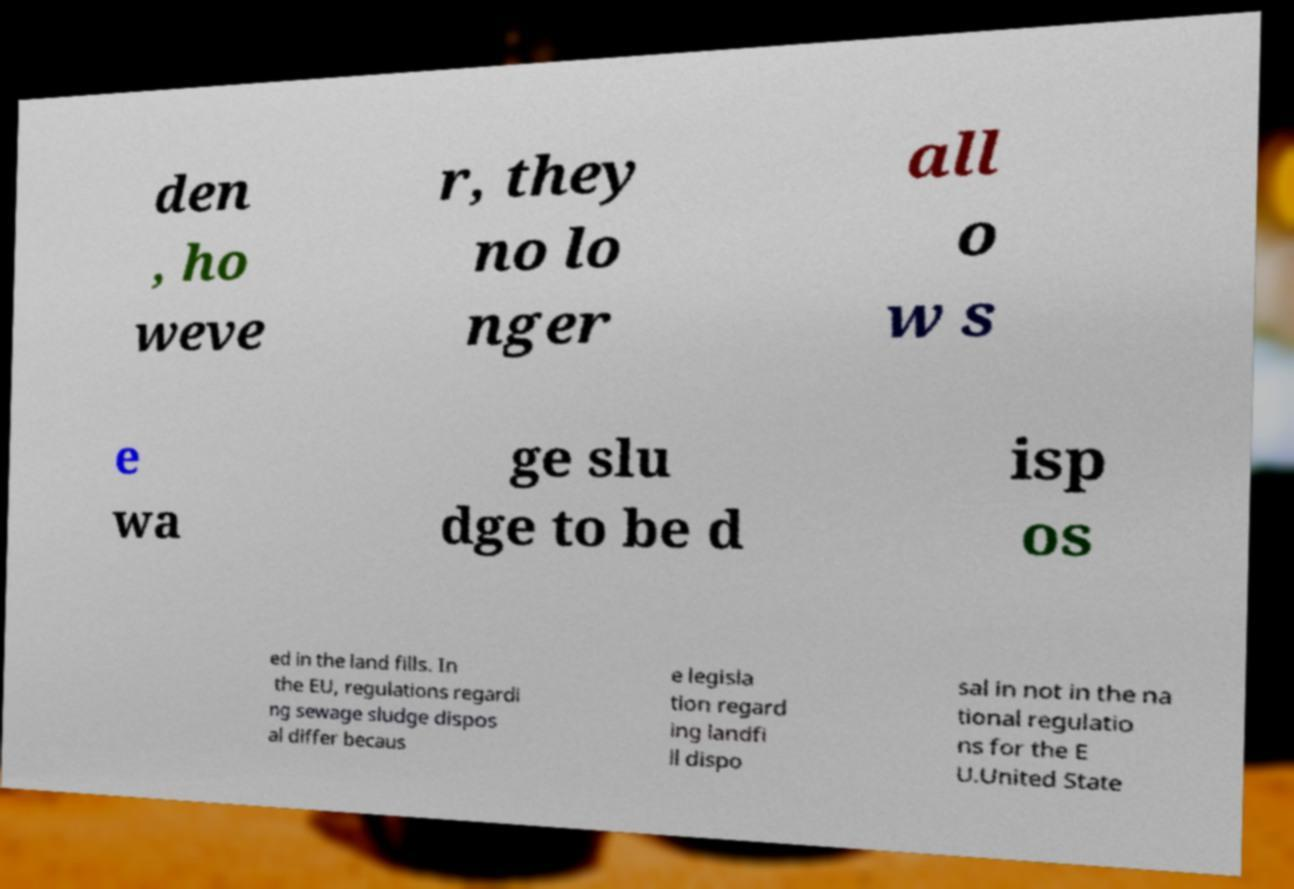Please identify and transcribe the text found in this image. den , ho weve r, they no lo nger all o w s e wa ge slu dge to be d isp os ed in the land fills. In the EU, regulations regardi ng sewage sludge dispos al differ becaus e legisla tion regard ing landfi ll dispo sal in not in the na tional regulatio ns for the E U.United State 